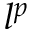<formula> <loc_0><loc_0><loc_500><loc_500>l ^ { p }</formula> 